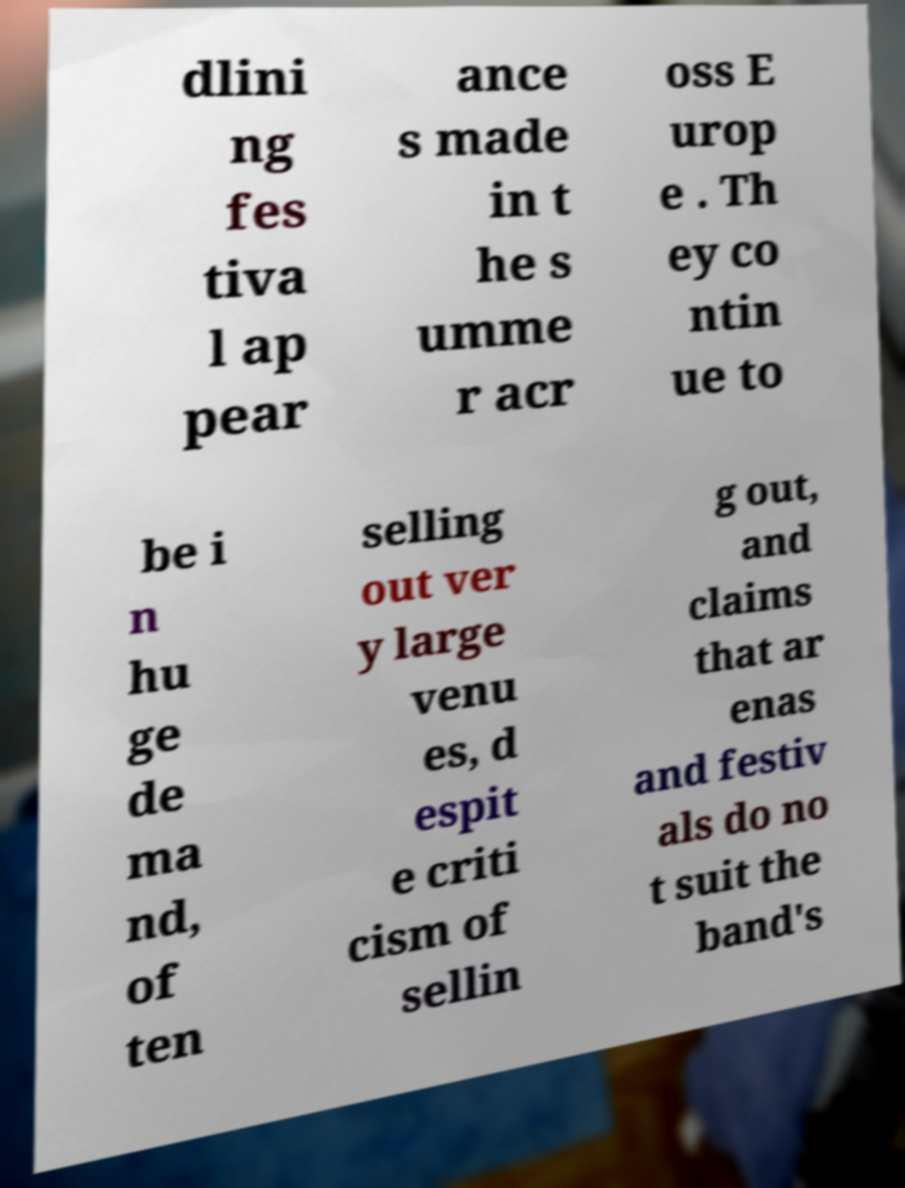Could you extract and type out the text from this image? dlini ng fes tiva l ap pear ance s made in t he s umme r acr oss E urop e . Th ey co ntin ue to be i n hu ge de ma nd, of ten selling out ver y large venu es, d espit e criti cism of sellin g out, and claims that ar enas and festiv als do no t suit the band's 